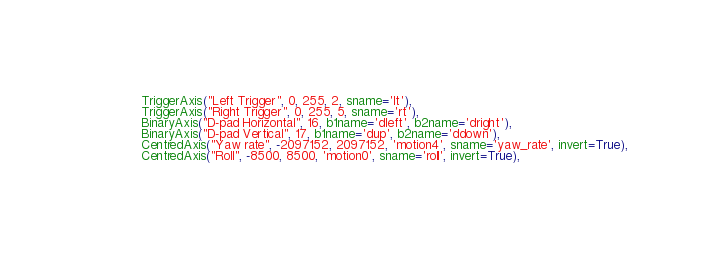Convert code to text. <code><loc_0><loc_0><loc_500><loc_500><_Python_>            TriggerAxis("Left Trigger", 0, 255, 2, sname='lt'),
            TriggerAxis("Right Trigger", 0, 255, 5, sname='rt'),
            BinaryAxis("D-pad Horizontal", 16, b1name='dleft', b2name='dright'),
            BinaryAxis("D-pad Vertical", 17, b1name='dup', b2name='ddown'),
            CentredAxis("Yaw rate", -2097152, 2097152, 'motion4', sname='yaw_rate', invert=True),
            CentredAxis("Roll", -8500, 8500, 'motion0', sname='roll', invert=True),</code> 